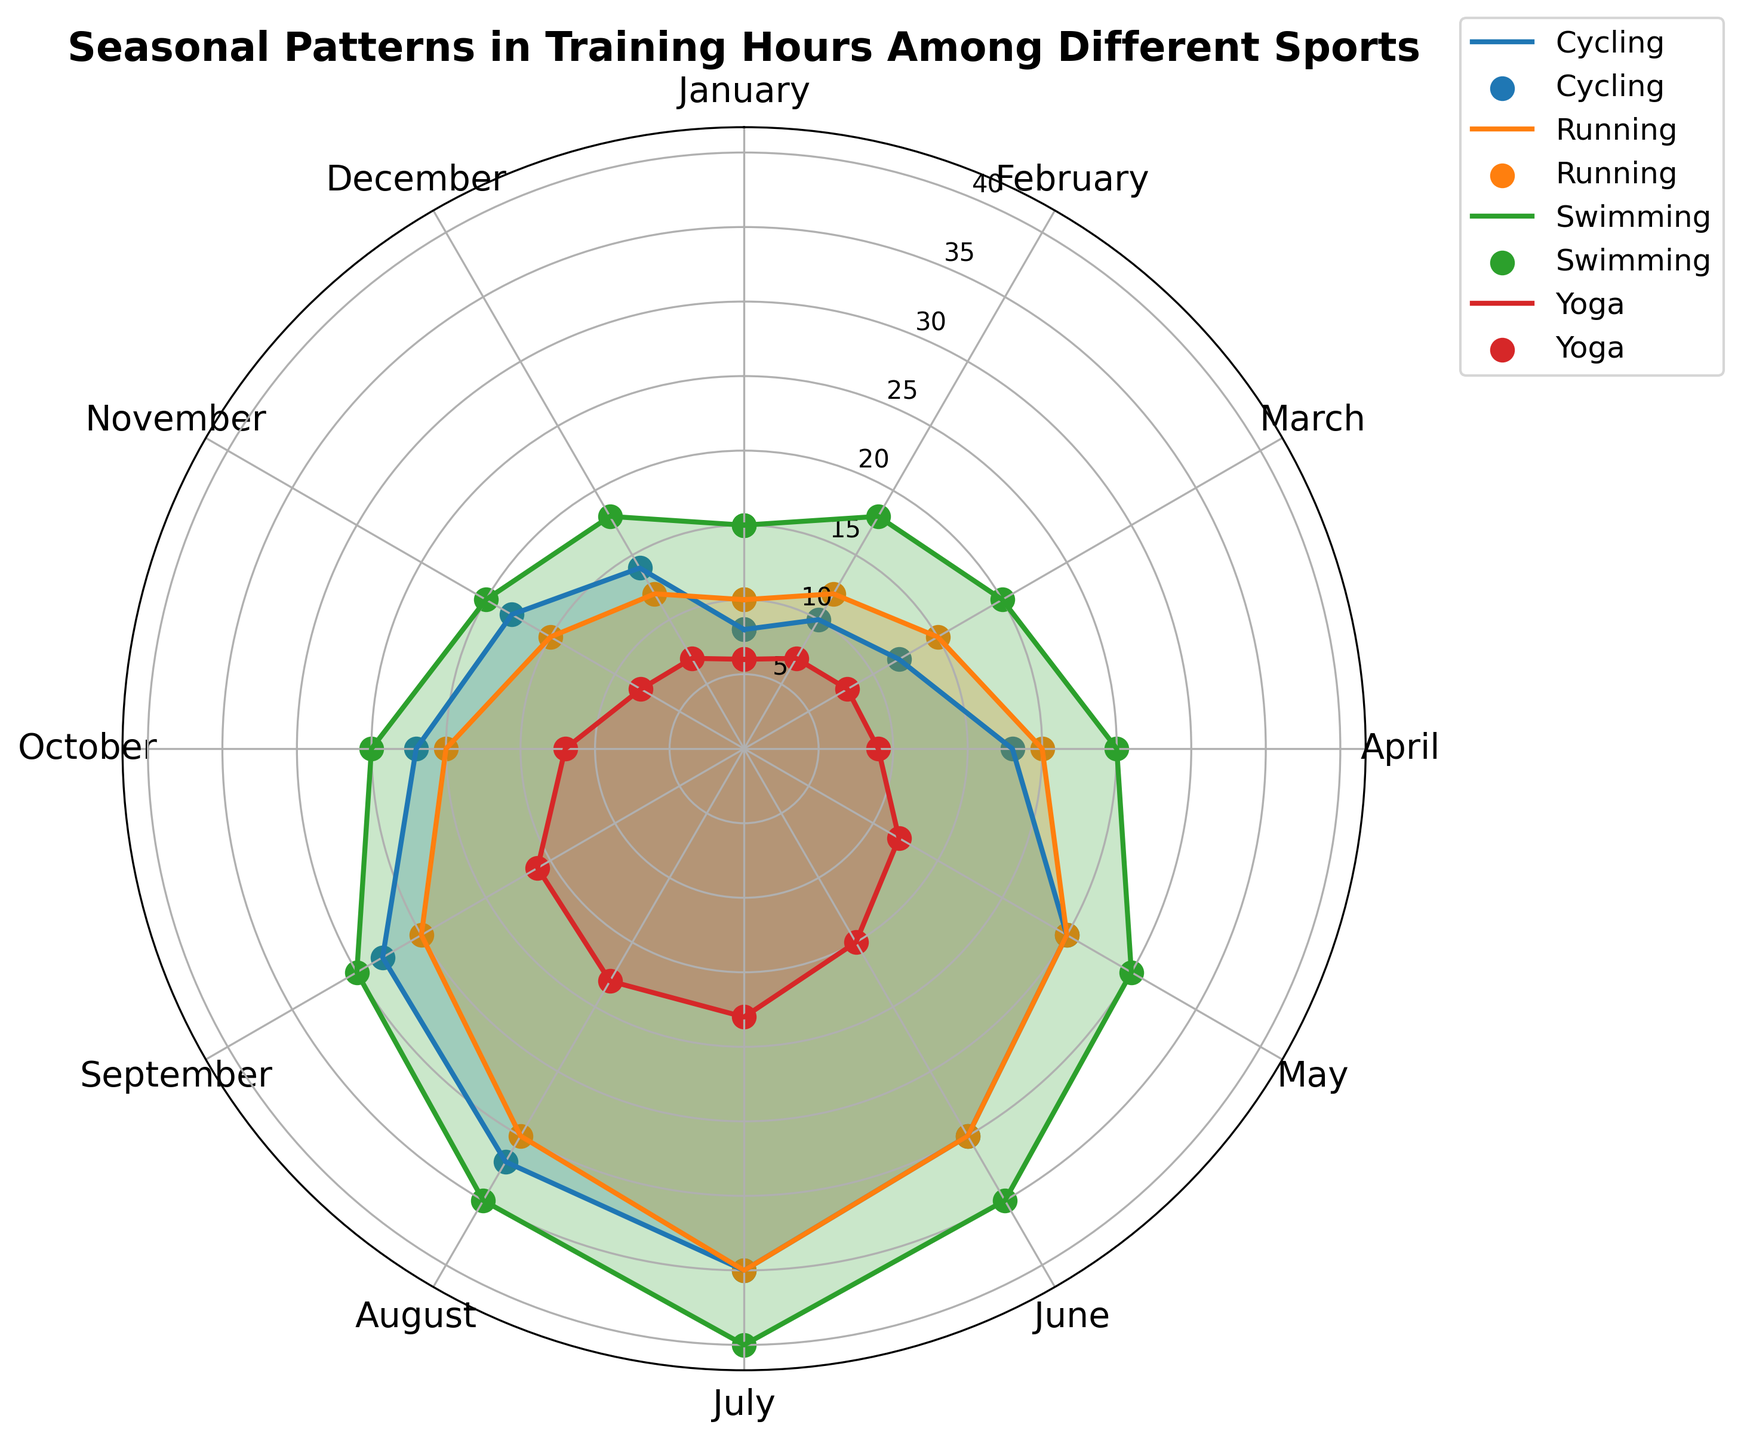How do training hours for swimming fluctuate throughout the year? Examining the figure, you can see that training hours for swimming gradually increase from January to July, peaking in July, and then gradually decrease towards December.
Answer: Training hours for swimming peak in July and are lowest in January and December Which sport has the highest training hours in the peak month of July? By looking at July in the figure, you can identify that both swimming and running reach 40 and 35 training hours respectively, but swimming is the highest among all sports.
Answer: Swimming During which months does yoga's training time plateau or show minimal changes? Observing yoga's trend, we can see minimal fluctuation between July and August, where training hours remain constant at 18.
Answer: July and August When comparing cycling and running, which sport has more training hours in the month of October? By analyzing the October segment for both sports: Cycling and Running, it is clear that running has 20 hours, while cycling has 22 hours. Thus, cycling has more training hours in October.
Answer: Cycling Calculate the total training hours combined for swimming and running in June. From the figure, note swimming has 35 training hours in June and running has 30. Adding these values gives 35 + 30 = 65 training hours.
Answer: 65 hours Which sport shows the most significant increase in training hours from January to July? Evaluating the increase for each sport, we observe that swimming increases from 15 to 40 hours, running from 10 to 35 hours, cycling from 8 to 35 hours, and yoga from 6 to 18 hours. Swimming shows an increase of 25 hours, the largest increase.
Answer: Swimming How does the overall pattern in training hours differ between cycling and running throughout the year? By comparing the yearly trends of cycling and running in the figure: running shows a consistent gradual increase from January to July, and then a decrease. In comparison, cycling shows a sharper increase and a slight plateau in the later months.
Answer: Cycling increases more sharply and plateaus, while running increases gradually and then decreases Which sport exhibits the least variation in training hours throughout the year? Looking at the training hours for each sport, yoga shows the least variation compared to others, ranging from 6 to 18 hours.
Answer: Yoga What is the average training hour in September for all sports? To compute the average training hours for September: Swimming (30), Running (25), Cycling (28), and Yoga (16). The average is calculated as (30 + 25 + 28 + 16) / 4 = 24.75 hours.
Answer: 24.75 hours Which months do all sports show an increase in training hours compared to the previous month? Examining the trends for all sports, we observe consistent increases from April to July.
Answer: From April to July 